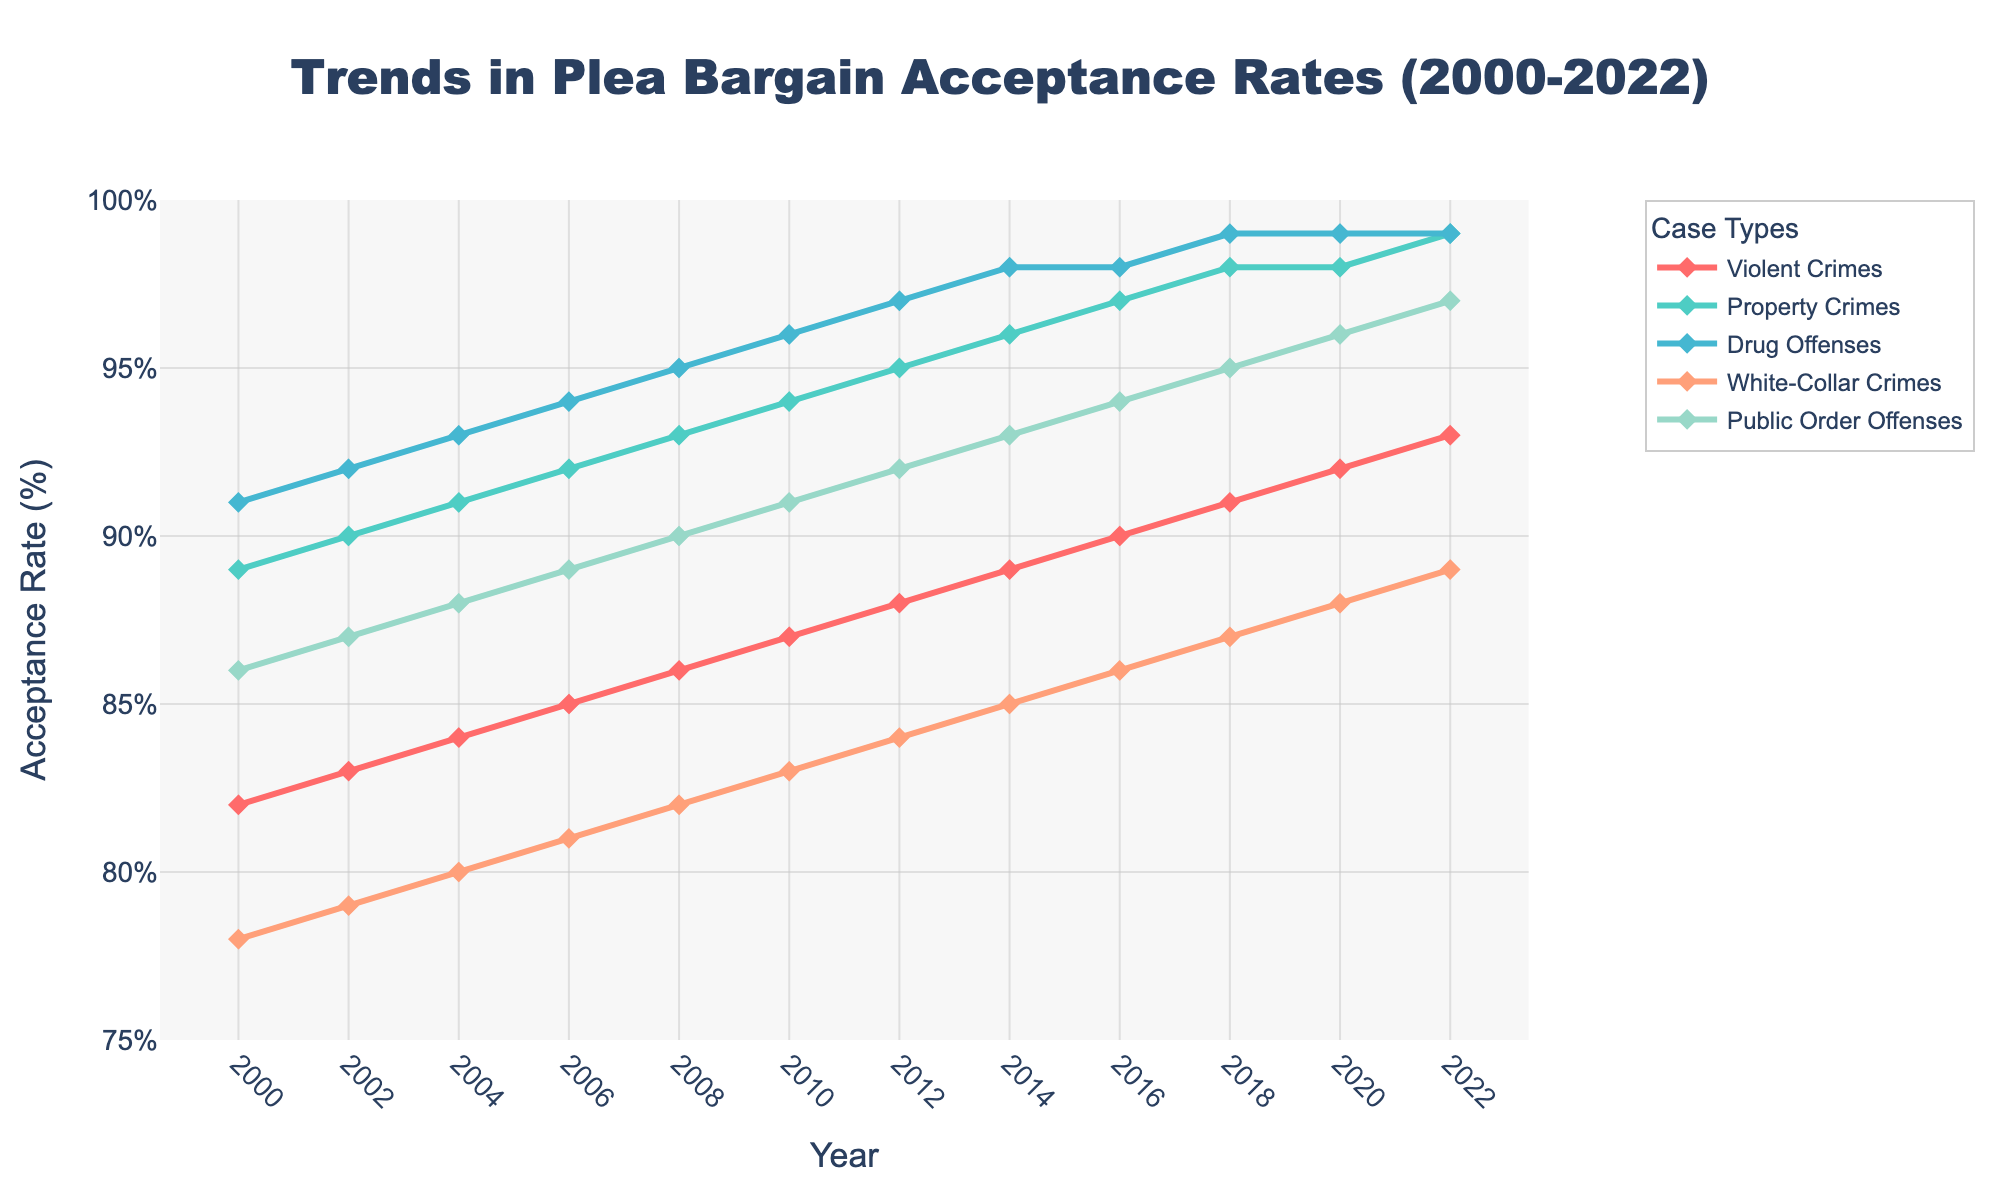What is the overall trend in plea bargain acceptance rates for Drug Offenses from 2000 to 2022? The plot shows that the acceptance rate for Drug Offenses has consistently increased from 2000 to 2022. Starting at 91% in 2000, it steadily rises to reach 99% by 2018 and maintains this rate through 2022.
Answer: Consistent increase Which case type had the highest plea bargain acceptance rate in 2000? In 2000, the plea bargain acceptance rate for Property Crimes was the highest among the case types, with a rate of 89%.
Answer: Property Crimes By how many percentage points did the plea bargain acceptance rate for Violent Crimes increase between 2000 and 2022? The plea bargain acceptance rate for Violent Crimes increased from 82% in 2000 to 93% in 2022. The difference is 93% - 82% = 11 percentage points.
Answer: 11 percentage points How do the acceptance rates for White-Collar Crimes compare to those for Public Order Offenses in 2022? In 2022, the plea bargain acceptance rate for White-Collar Crimes was 89%, and for Public Order Offenses, it was 97%. White-Collar Crimes have a lower acceptance rate compared to Public Order Offenses by 8 percentage points.
Answer: White-Collar Crimes are lower by 8 percentage points What is the rate of increase in acceptance rates for Property Crimes from 2000 to 2022 in terms of percentage points per year? The acceptance rate for Property Crimes increased from 89% in 2000 to 99% in 2022, an increase of 10 percentage points over 22 years. The rate of increase is 10/22 ≈ 0.45 percentage points per year.
Answer: Approximately 0.45 percentage points per year Which case type has shown the most consistent increase with no periods of decline from 2000 to 2022? Drug Offenses and Public Order Offenses both show a consistent increase with no periods of decline throughout the entire timeline.
Answer: Drug Offenses and Public Order Offenses Between which two consecutive years did the plea bargain acceptance rate for Violent Crimes increase the most? The acceptance rate for Violent Crimes increased the most between 2004 and 2006, from 84% to 85% which is the largest single step change of 1 percentage point during the given periods.
Answer: Between 2004 and 2006 In what year did the plea bargain acceptance rate for Public Order Offenses first reach 90%? The plea bargain acceptance rate for Public Order Offenses first reached 90% in the year 2008.
Answer: 2008 